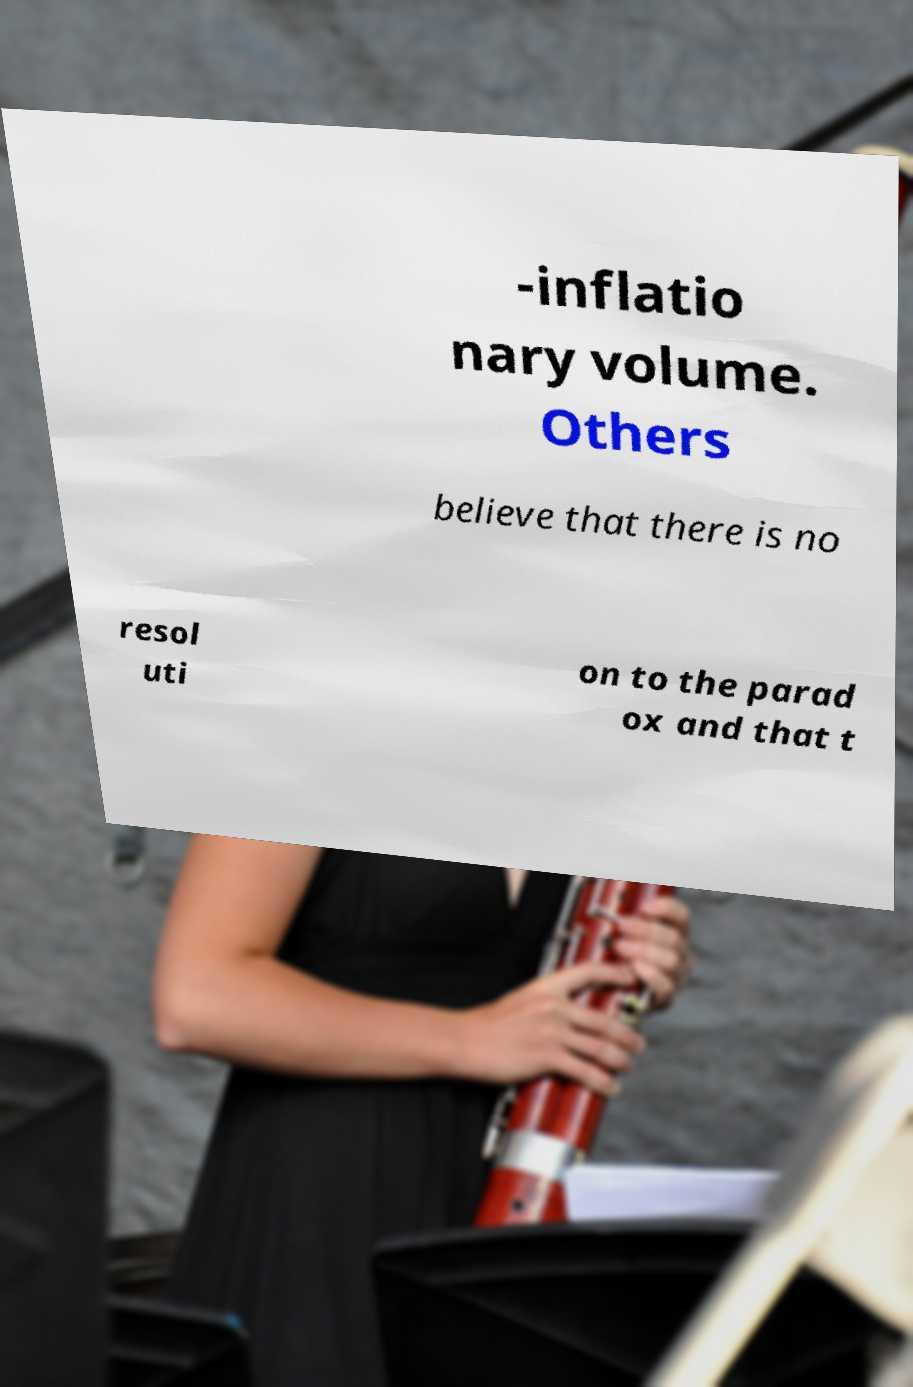Could you assist in decoding the text presented in this image and type it out clearly? -inflatio nary volume. Others believe that there is no resol uti on to the parad ox and that t 